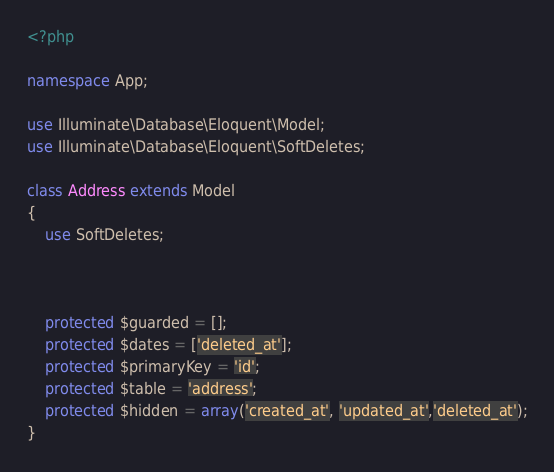Convert code to text. <code><loc_0><loc_0><loc_500><loc_500><_PHP_><?php

namespace App;

use Illuminate\Database\Eloquent\Model;
use Illuminate\Database\Eloquent\SoftDeletes;

class Address extends Model
{
    use SoftDeletes;



    protected $guarded = [];
    protected $dates = ['deleted_at'];
    protected $primaryKey = 'id';
    protected $table = 'address';
    protected $hidden = array('created_at', 'updated_at','deleted_at');
}
</code> 